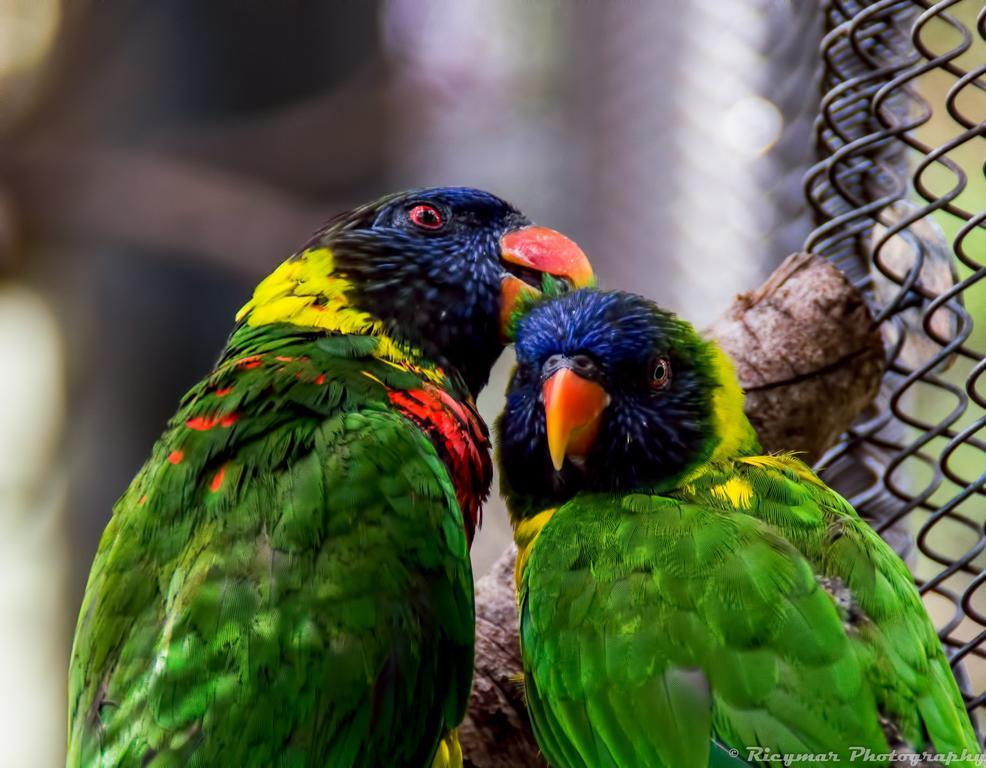What type of animals are in the image? There are parrots in the image. What can be seen on the right side of the image? There is a grill on the right side of the image. How many eggs are being cooked on the grill in the image? There is no grill or eggs present in the image; it only features parrots. What type of account is being discussed in the image? There is no account mentioned or depicted in the image. 